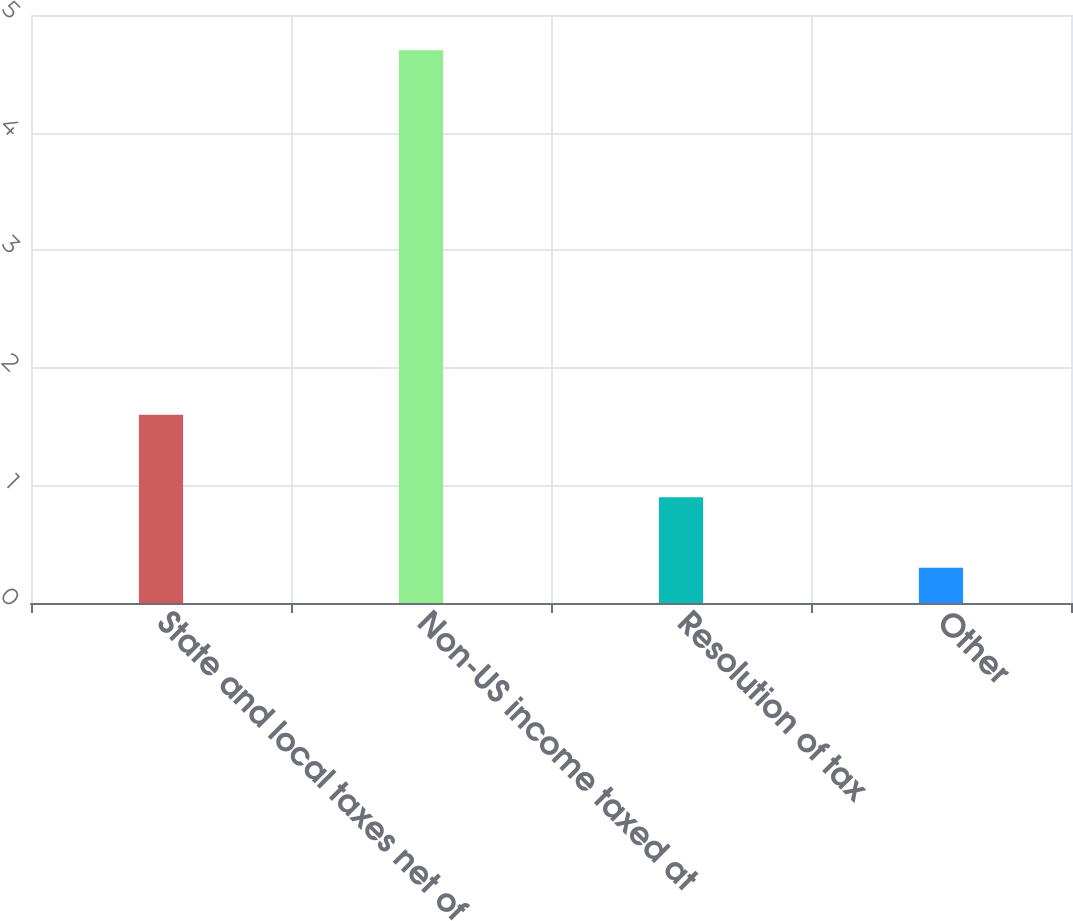Convert chart to OTSL. <chart><loc_0><loc_0><loc_500><loc_500><bar_chart><fcel>State and local taxes net of<fcel>Non-US income taxed at<fcel>Resolution of tax<fcel>Other<nl><fcel>1.6<fcel>4.7<fcel>0.9<fcel>0.3<nl></chart> 